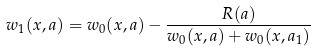Convert formula to latex. <formula><loc_0><loc_0><loc_500><loc_500>w _ { 1 } ( x , a ) = w _ { 0 } ( x , a ) - \frac { R ( a ) } { w _ { 0 } ( x , a ) + w _ { 0 } ( x , a _ { 1 } ) }</formula> 